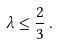Convert formula to latex. <formula><loc_0><loc_0><loc_500><loc_500>\lambda \leq \frac { 2 } { 3 } \, .</formula> 